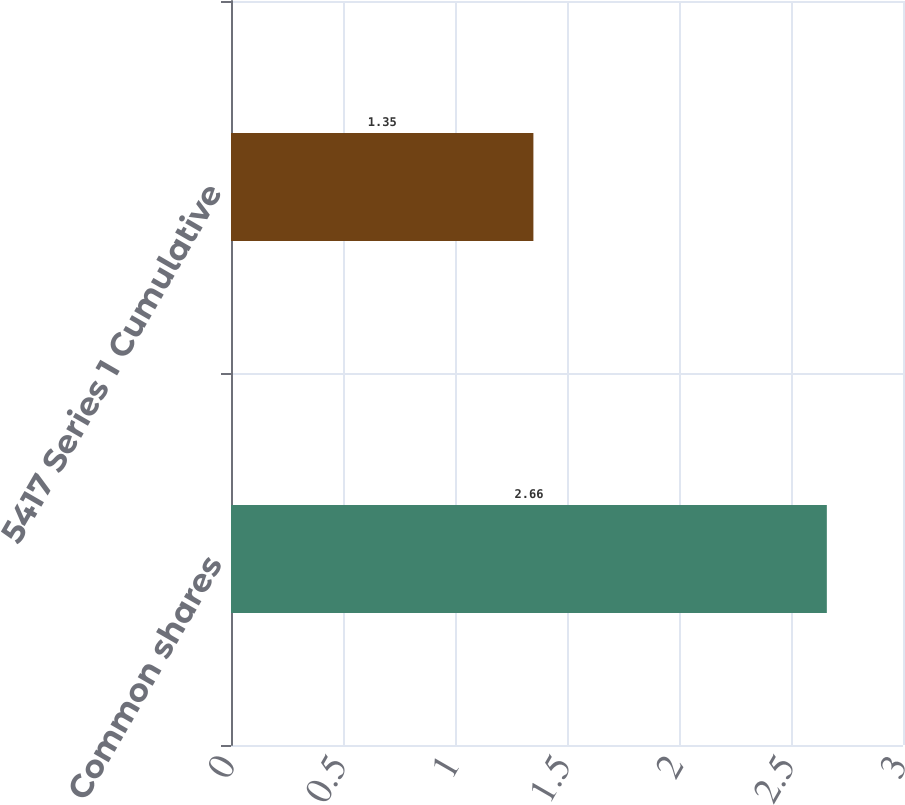Convert chart. <chart><loc_0><loc_0><loc_500><loc_500><bar_chart><fcel>Common shares<fcel>5417 Series 1 Cumulative<nl><fcel>2.66<fcel>1.35<nl></chart> 